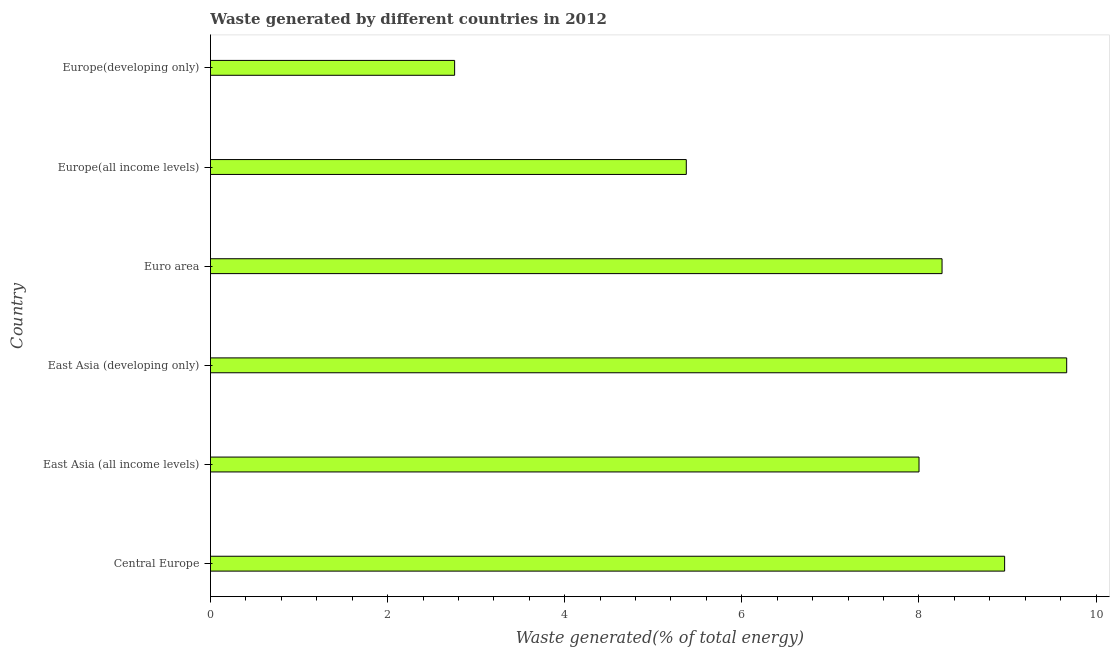Does the graph contain any zero values?
Your answer should be very brief. No. Does the graph contain grids?
Your response must be concise. No. What is the title of the graph?
Give a very brief answer. Waste generated by different countries in 2012. What is the label or title of the X-axis?
Make the answer very short. Waste generated(% of total energy). What is the label or title of the Y-axis?
Give a very brief answer. Country. What is the amount of waste generated in Euro area?
Your answer should be compact. 8.26. Across all countries, what is the maximum amount of waste generated?
Offer a terse response. 9.67. Across all countries, what is the minimum amount of waste generated?
Your answer should be very brief. 2.76. In which country was the amount of waste generated maximum?
Make the answer very short. East Asia (developing only). In which country was the amount of waste generated minimum?
Ensure brevity in your answer.  Europe(developing only). What is the sum of the amount of waste generated?
Provide a short and direct response. 43.03. What is the difference between the amount of waste generated in East Asia (developing only) and Europe(all income levels)?
Provide a succinct answer. 4.3. What is the average amount of waste generated per country?
Give a very brief answer. 7.17. What is the median amount of waste generated?
Your response must be concise. 8.13. What is the ratio of the amount of waste generated in Europe(all income levels) to that in Europe(developing only)?
Provide a succinct answer. 1.95. Is the amount of waste generated in East Asia (all income levels) less than that in Euro area?
Provide a succinct answer. Yes. Is the difference between the amount of waste generated in Europe(all income levels) and Europe(developing only) greater than the difference between any two countries?
Your answer should be very brief. No. What is the difference between the highest and the second highest amount of waste generated?
Keep it short and to the point. 0.7. Is the sum of the amount of waste generated in Central Europe and Europe(developing only) greater than the maximum amount of waste generated across all countries?
Keep it short and to the point. Yes. What is the difference between the highest and the lowest amount of waste generated?
Keep it short and to the point. 6.91. In how many countries, is the amount of waste generated greater than the average amount of waste generated taken over all countries?
Your answer should be very brief. 4. Are all the bars in the graph horizontal?
Provide a short and direct response. Yes. Are the values on the major ticks of X-axis written in scientific E-notation?
Your answer should be very brief. No. What is the Waste generated(% of total energy) of Central Europe?
Your answer should be compact. 8.97. What is the Waste generated(% of total energy) of East Asia (all income levels)?
Your answer should be compact. 8. What is the Waste generated(% of total energy) in East Asia (developing only)?
Keep it short and to the point. 9.67. What is the Waste generated(% of total energy) of Euro area?
Offer a terse response. 8.26. What is the Waste generated(% of total energy) in Europe(all income levels)?
Ensure brevity in your answer.  5.37. What is the Waste generated(% of total energy) of Europe(developing only)?
Your answer should be compact. 2.76. What is the difference between the Waste generated(% of total energy) in Central Europe and East Asia (all income levels)?
Your answer should be compact. 0.97. What is the difference between the Waste generated(% of total energy) in Central Europe and East Asia (developing only)?
Your answer should be very brief. -0.7. What is the difference between the Waste generated(% of total energy) in Central Europe and Euro area?
Make the answer very short. 0.71. What is the difference between the Waste generated(% of total energy) in Central Europe and Europe(all income levels)?
Your response must be concise. 3.59. What is the difference between the Waste generated(% of total energy) in Central Europe and Europe(developing only)?
Your answer should be compact. 6.21. What is the difference between the Waste generated(% of total energy) in East Asia (all income levels) and East Asia (developing only)?
Ensure brevity in your answer.  -1.67. What is the difference between the Waste generated(% of total energy) in East Asia (all income levels) and Euro area?
Provide a short and direct response. -0.26. What is the difference between the Waste generated(% of total energy) in East Asia (all income levels) and Europe(all income levels)?
Ensure brevity in your answer.  2.63. What is the difference between the Waste generated(% of total energy) in East Asia (all income levels) and Europe(developing only)?
Give a very brief answer. 5.24. What is the difference between the Waste generated(% of total energy) in East Asia (developing only) and Euro area?
Provide a short and direct response. 1.41. What is the difference between the Waste generated(% of total energy) in East Asia (developing only) and Europe(all income levels)?
Provide a short and direct response. 4.3. What is the difference between the Waste generated(% of total energy) in East Asia (developing only) and Europe(developing only)?
Provide a succinct answer. 6.91. What is the difference between the Waste generated(% of total energy) in Euro area and Europe(all income levels)?
Provide a short and direct response. 2.89. What is the difference between the Waste generated(% of total energy) in Euro area and Europe(developing only)?
Give a very brief answer. 5.5. What is the difference between the Waste generated(% of total energy) in Europe(all income levels) and Europe(developing only)?
Ensure brevity in your answer.  2.62. What is the ratio of the Waste generated(% of total energy) in Central Europe to that in East Asia (all income levels)?
Provide a succinct answer. 1.12. What is the ratio of the Waste generated(% of total energy) in Central Europe to that in East Asia (developing only)?
Keep it short and to the point. 0.93. What is the ratio of the Waste generated(% of total energy) in Central Europe to that in Euro area?
Your answer should be compact. 1.09. What is the ratio of the Waste generated(% of total energy) in Central Europe to that in Europe(all income levels)?
Give a very brief answer. 1.67. What is the ratio of the Waste generated(% of total energy) in Central Europe to that in Europe(developing only)?
Your response must be concise. 3.25. What is the ratio of the Waste generated(% of total energy) in East Asia (all income levels) to that in East Asia (developing only)?
Keep it short and to the point. 0.83. What is the ratio of the Waste generated(% of total energy) in East Asia (all income levels) to that in Europe(all income levels)?
Make the answer very short. 1.49. What is the ratio of the Waste generated(% of total energy) in East Asia (all income levels) to that in Europe(developing only)?
Give a very brief answer. 2.9. What is the ratio of the Waste generated(% of total energy) in East Asia (developing only) to that in Euro area?
Keep it short and to the point. 1.17. What is the ratio of the Waste generated(% of total energy) in East Asia (developing only) to that in Europe(all income levels)?
Make the answer very short. 1.8. What is the ratio of the Waste generated(% of total energy) in East Asia (developing only) to that in Europe(developing only)?
Keep it short and to the point. 3.51. What is the ratio of the Waste generated(% of total energy) in Euro area to that in Europe(all income levels)?
Your answer should be compact. 1.54. What is the ratio of the Waste generated(% of total energy) in Euro area to that in Europe(developing only)?
Provide a short and direct response. 3. What is the ratio of the Waste generated(% of total energy) in Europe(all income levels) to that in Europe(developing only)?
Offer a very short reply. 1.95. 